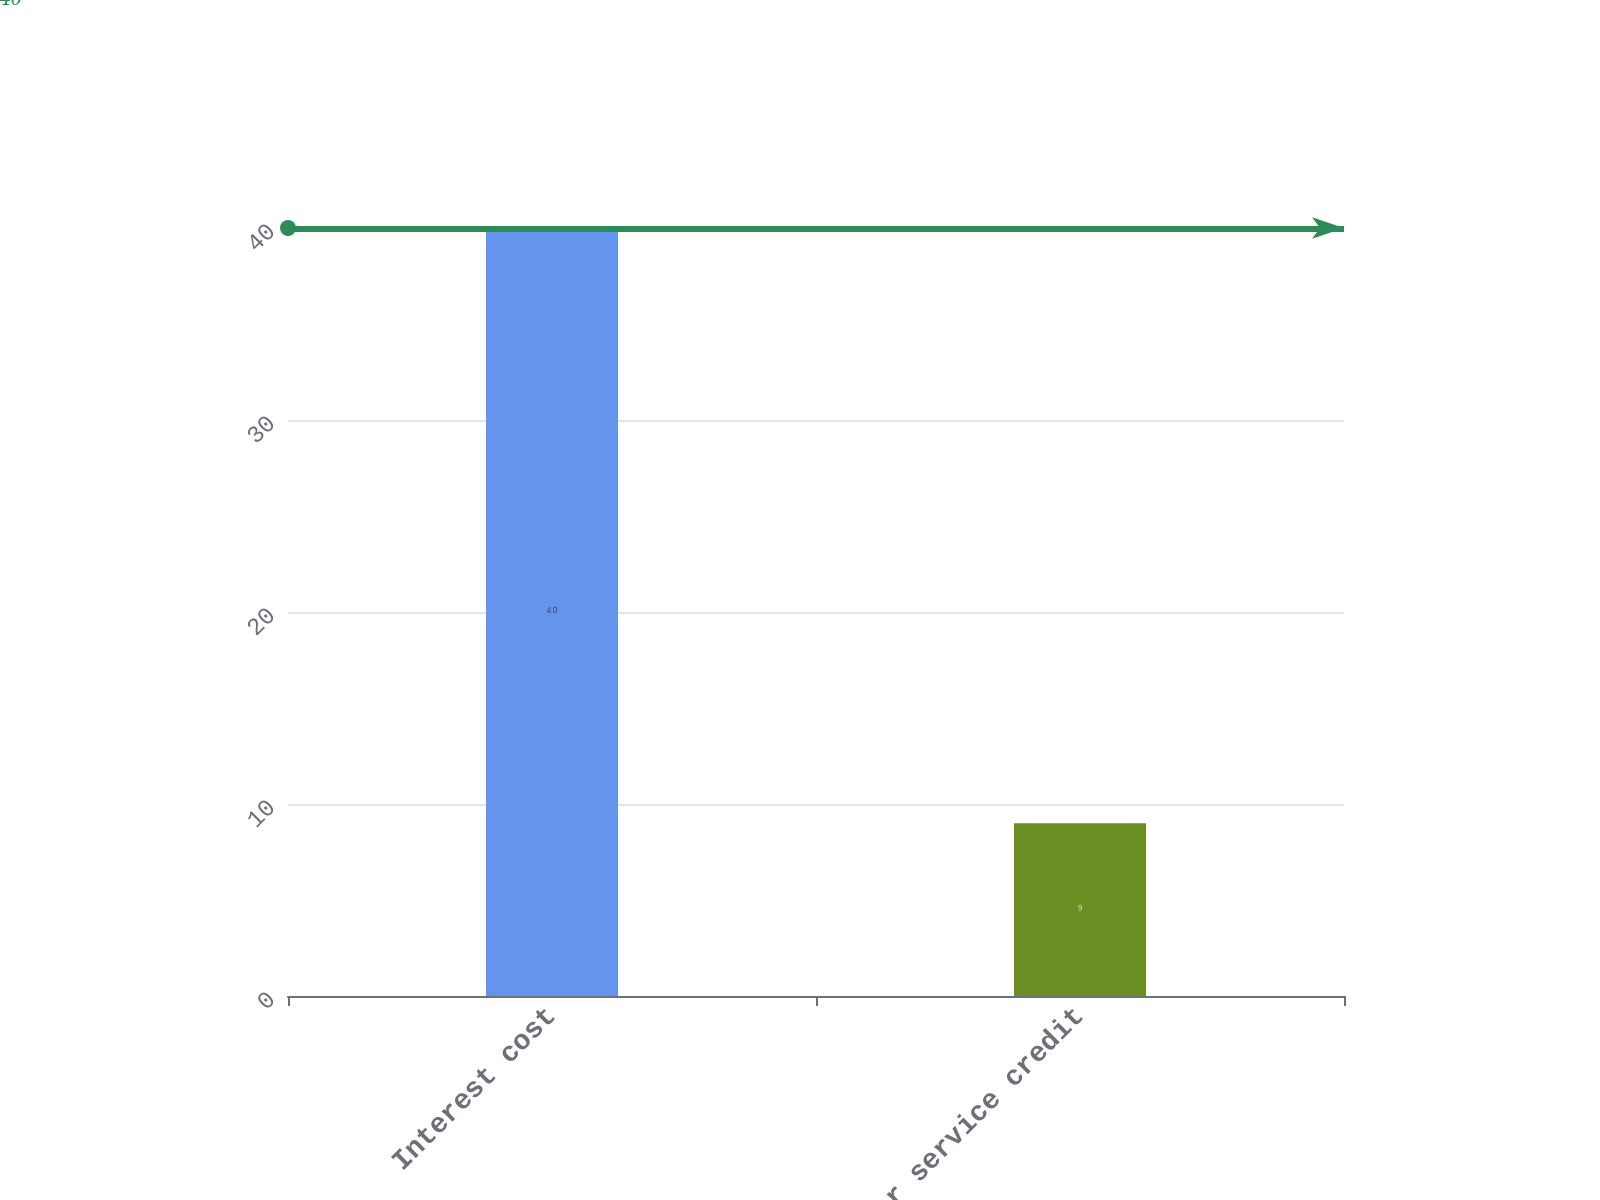<chart> <loc_0><loc_0><loc_500><loc_500><bar_chart><fcel>Interest cost<fcel>Prior service credit<nl><fcel>40<fcel>9<nl></chart> 